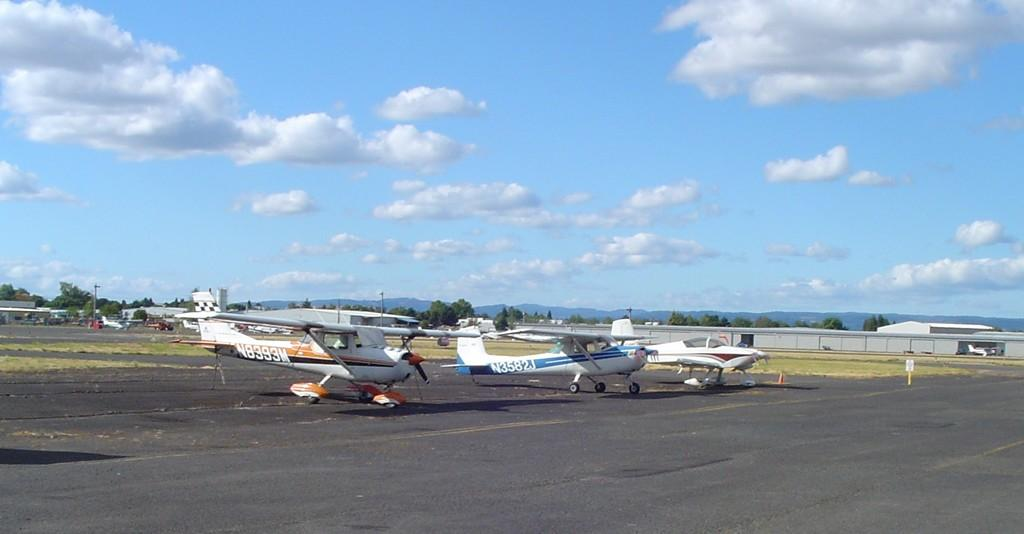<image>
Give a short and clear explanation of the subsequent image. N8393M logo on a airplane and N3582J logo on a blue and white airplane. 